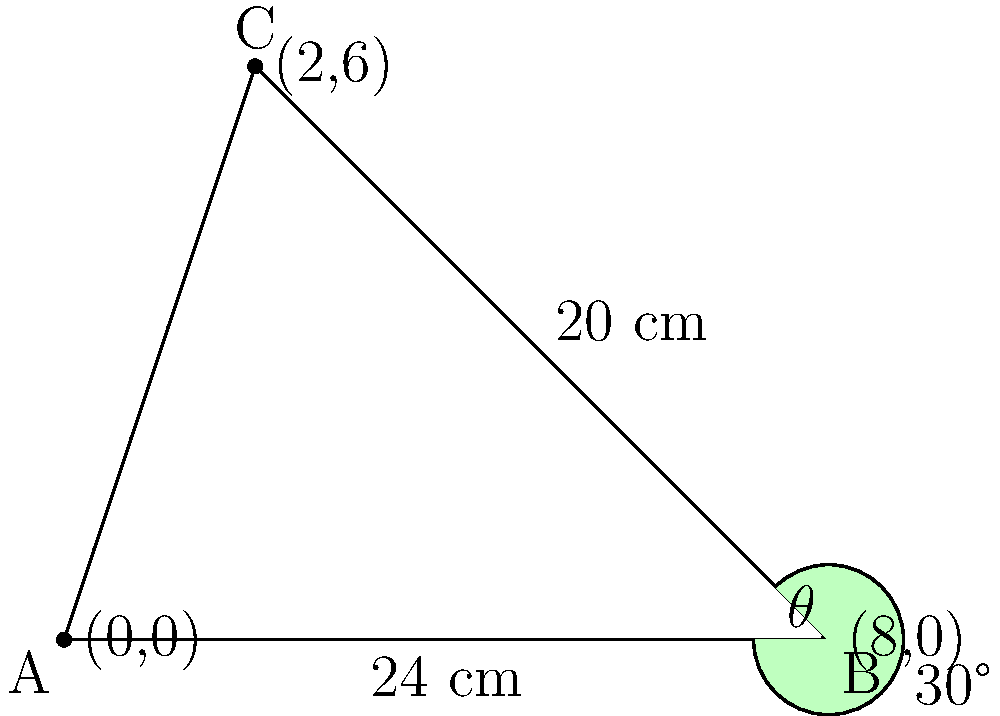At a Delta Rae concert, you notice the guitarist's instrument has an interesting shape. The body and neck form a triangle, where the body (AB) measures 24 cm, and the side of the body connected to the neck (BC) is 20 cm. The angle between these two sides ($\theta$) is 30°. What is the length of the guitar string (AC) to the nearest centimeter? To solve this problem, we'll use the law of sines. Let's approach this step-by-step:

1) First, let's recall the law of sines:
   $$\frac{a}{\sin A} = \frac{b}{\sin B} = \frac{c}{\sin C}$$
   where $a$, $b$, and $c$ are the lengths of the sides opposite to angles $A$, $B$, and $C$ respectively.

2) In our triangle:
   - Side $c$ (AB) = 24 cm
   - Side $a$ (BC) = 20 cm
   - Angle $C$ ($\theta$) = 30°
   - We need to find side $b$ (AC)

3) We can use the part of the law of sines that relates sides $a$ and $b$:
   $$\frac{a}{\sin A} = \frac{b}{\sin C}$$

4) We know $a$, $C$, and need to find $b$. We don't know $A$, but we can find $\sin A$:
   $$\frac{20}{\sin A} = \frac{b}{\sin 30°}$$

5) Rearrange to solve for $b$:
   $$b = \frac{20 \sin 30°}{\sin A}$$

6) We don't know $\sin A$, but we can find it using the sine law again:
   $$\frac{24}{\sin 30°} = \frac{20}{\sin A}$$

7) Solve for $\sin A$:
   $$\sin A = \frac{20 \sin 30°}{24} \approx 0.4167$$

8) Now we can calculate $b$:
   $$b = \frac{20 \sin 30°}{0.4167} \approx 24.00 \text{ cm}$$

9) Rounding to the nearest centimeter, we get 24 cm.
Answer: 24 cm 